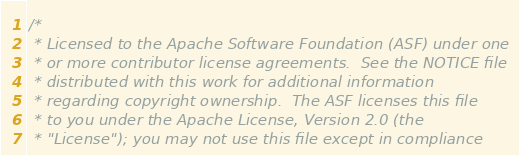<code> <loc_0><loc_0><loc_500><loc_500><_Scala_>/*
 * Licensed to the Apache Software Foundation (ASF) under one
 * or more contributor license agreements.  See the NOTICE file
 * distributed with this work for additional information
 * regarding copyright ownership.  The ASF licenses this file
 * to you under the Apache License, Version 2.0 (the
 * "License"); you may not use this file except in compliance</code> 